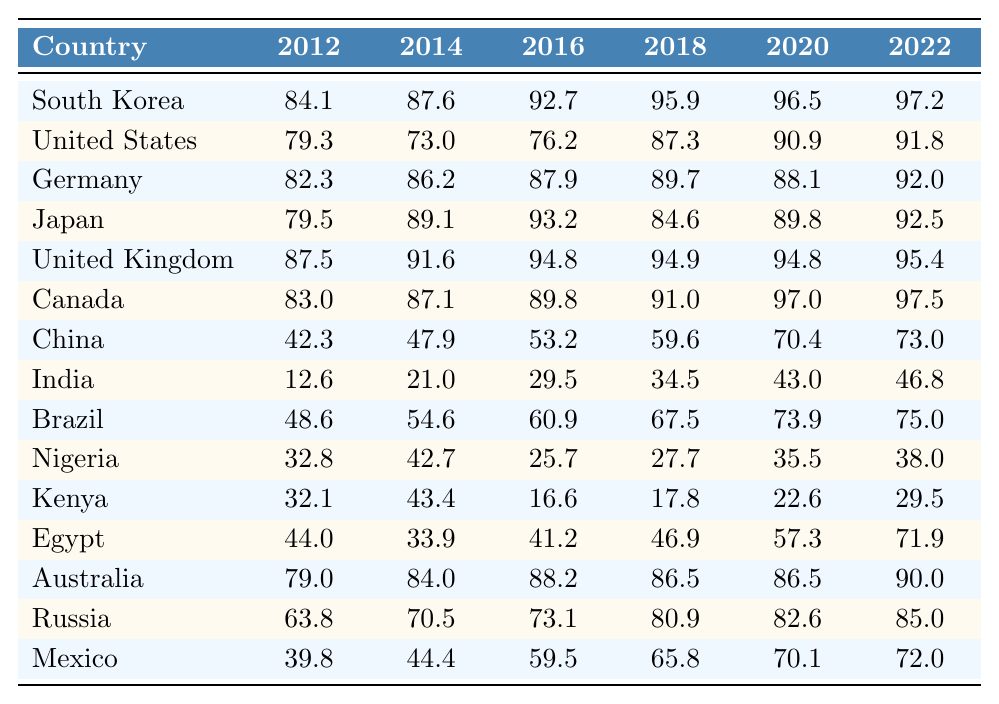What was the internet penetration rate in South Korea in 2012? The table shows that South Korea had an internet penetration rate of 84.1% in 2012.
Answer: 84.1% Which country had the highest internet penetration rate in 2022? By examining the last column of the table for 2022, South Korea has the highest internet penetration rate at 97.2%.
Answer: South Korea What was the difference in internet penetration rates in the United States between 2014 and 2020? The United States had a rate of 73.0% in 2014 and 90.9% in 2020. The difference is 90.9 - 73.0 = 17.9%.
Answer: 17.9% Is the internet penetration rate in China above 70% in 2020? The table indicates that China's internet penetration rate in 2020 was 70.4%, which is indeed above 70%.
Answer: Yes What is the average internet penetration rate in Germany from 2012 to 2022? The values for Germany over these years are 82.3%, 86.2%, 87.9%, 89.7%, 88.1%, and 92.0%. Adding these gives 516.2%, and dividing by 6 results in an average of 86.03%.
Answer: 86.03% Which country had the lowest internet penetration rate in 2016? Checking the 2016 column, India had the lowest rate at 29.5%.
Answer: India Between 2018 and 2022, did Nigeria's internet penetration rate show an increase? Nigeria had rates of 27.7% in 2018 and 38.0% in 2022. Since 38.0% > 27.7%, this indicates an increase.
Answer: Yes What was the change in internet penetration rate for Brazil from 2012 to 2022? In 2012, Brazil's rate was 48.6% and in 2022 it was 75.0%. The change is 75.0 - 48.6 = 26.4%.
Answer: 26.4% Which country had an internet penetration rate of 12.6% in 2012? The table shows that India had an internet penetration rate of 12.6% in 2012.
Answer: India Summarize the trend for internet penetration in Kenya from 2012 to 2022? Kenya started at 32.1% in 2012, peaked briefly but fluctuated down to 16.6% in 2016, then increased slowly to 29.5% in 2022. Overall, the trend appears to be upwards despite the dip in 2016.
Answer: Fluctuated, overall increasing 